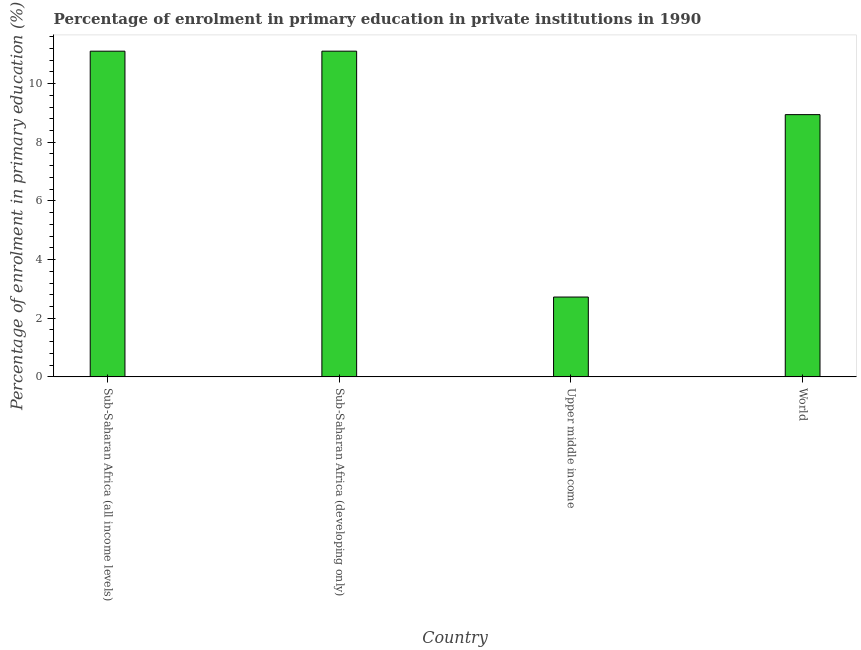Does the graph contain any zero values?
Your response must be concise. No. What is the title of the graph?
Your answer should be compact. Percentage of enrolment in primary education in private institutions in 1990. What is the label or title of the Y-axis?
Your answer should be compact. Percentage of enrolment in primary education (%). What is the enrolment percentage in primary education in Sub-Saharan Africa (developing only)?
Your response must be concise. 11.1. Across all countries, what is the maximum enrolment percentage in primary education?
Offer a very short reply. 11.1. Across all countries, what is the minimum enrolment percentage in primary education?
Your answer should be very brief. 2.72. In which country was the enrolment percentage in primary education maximum?
Keep it short and to the point. Sub-Saharan Africa (developing only). In which country was the enrolment percentage in primary education minimum?
Your answer should be compact. Upper middle income. What is the sum of the enrolment percentage in primary education?
Your answer should be compact. 33.87. What is the difference between the enrolment percentage in primary education in Sub-Saharan Africa (developing only) and Upper middle income?
Offer a terse response. 8.38. What is the average enrolment percentage in primary education per country?
Provide a succinct answer. 8.47. What is the median enrolment percentage in primary education?
Make the answer very short. 10.02. In how many countries, is the enrolment percentage in primary education greater than 5.6 %?
Provide a short and direct response. 3. What is the ratio of the enrolment percentage in primary education in Sub-Saharan Africa (developing only) to that in World?
Provide a succinct answer. 1.24. Is the enrolment percentage in primary education in Sub-Saharan Africa (all income levels) less than that in World?
Your answer should be very brief. No. What is the difference between the highest and the lowest enrolment percentage in primary education?
Offer a very short reply. 8.38. In how many countries, is the enrolment percentage in primary education greater than the average enrolment percentage in primary education taken over all countries?
Provide a succinct answer. 3. Are the values on the major ticks of Y-axis written in scientific E-notation?
Give a very brief answer. No. What is the Percentage of enrolment in primary education (%) of Sub-Saharan Africa (all income levels)?
Your response must be concise. 11.1. What is the Percentage of enrolment in primary education (%) of Sub-Saharan Africa (developing only)?
Give a very brief answer. 11.1. What is the Percentage of enrolment in primary education (%) of Upper middle income?
Provide a succinct answer. 2.72. What is the Percentage of enrolment in primary education (%) of World?
Your answer should be compact. 8.94. What is the difference between the Percentage of enrolment in primary education (%) in Sub-Saharan Africa (all income levels) and Sub-Saharan Africa (developing only)?
Make the answer very short. -0. What is the difference between the Percentage of enrolment in primary education (%) in Sub-Saharan Africa (all income levels) and Upper middle income?
Make the answer very short. 8.38. What is the difference between the Percentage of enrolment in primary education (%) in Sub-Saharan Africa (all income levels) and World?
Offer a terse response. 2.16. What is the difference between the Percentage of enrolment in primary education (%) in Sub-Saharan Africa (developing only) and Upper middle income?
Your answer should be very brief. 8.38. What is the difference between the Percentage of enrolment in primary education (%) in Sub-Saharan Africa (developing only) and World?
Provide a short and direct response. 2.16. What is the difference between the Percentage of enrolment in primary education (%) in Upper middle income and World?
Your answer should be very brief. -6.22. What is the ratio of the Percentage of enrolment in primary education (%) in Sub-Saharan Africa (all income levels) to that in Sub-Saharan Africa (developing only)?
Give a very brief answer. 1. What is the ratio of the Percentage of enrolment in primary education (%) in Sub-Saharan Africa (all income levels) to that in Upper middle income?
Provide a succinct answer. 4.08. What is the ratio of the Percentage of enrolment in primary education (%) in Sub-Saharan Africa (all income levels) to that in World?
Offer a terse response. 1.24. What is the ratio of the Percentage of enrolment in primary education (%) in Sub-Saharan Africa (developing only) to that in Upper middle income?
Give a very brief answer. 4.08. What is the ratio of the Percentage of enrolment in primary education (%) in Sub-Saharan Africa (developing only) to that in World?
Offer a terse response. 1.24. What is the ratio of the Percentage of enrolment in primary education (%) in Upper middle income to that in World?
Make the answer very short. 0.3. 